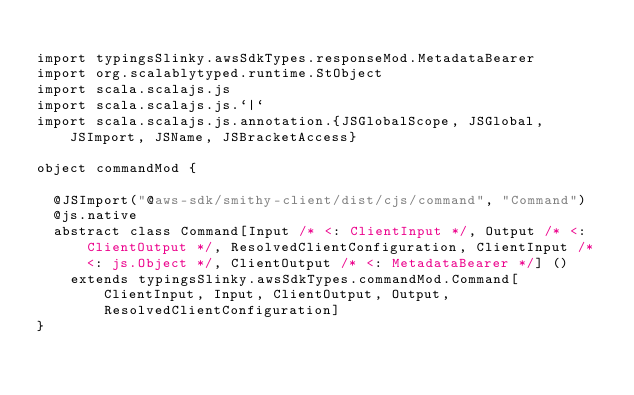<code> <loc_0><loc_0><loc_500><loc_500><_Scala_>
import typingsSlinky.awsSdkTypes.responseMod.MetadataBearer
import org.scalablytyped.runtime.StObject
import scala.scalajs.js
import scala.scalajs.js.`|`
import scala.scalajs.js.annotation.{JSGlobalScope, JSGlobal, JSImport, JSName, JSBracketAccess}

object commandMod {
  
  @JSImport("@aws-sdk/smithy-client/dist/cjs/command", "Command")
  @js.native
  abstract class Command[Input /* <: ClientInput */, Output /* <: ClientOutput */, ResolvedClientConfiguration, ClientInput /* <: js.Object */, ClientOutput /* <: MetadataBearer */] ()
    extends typingsSlinky.awsSdkTypes.commandMod.Command[ClientInput, Input, ClientOutput, Output, ResolvedClientConfiguration]
}
</code> 